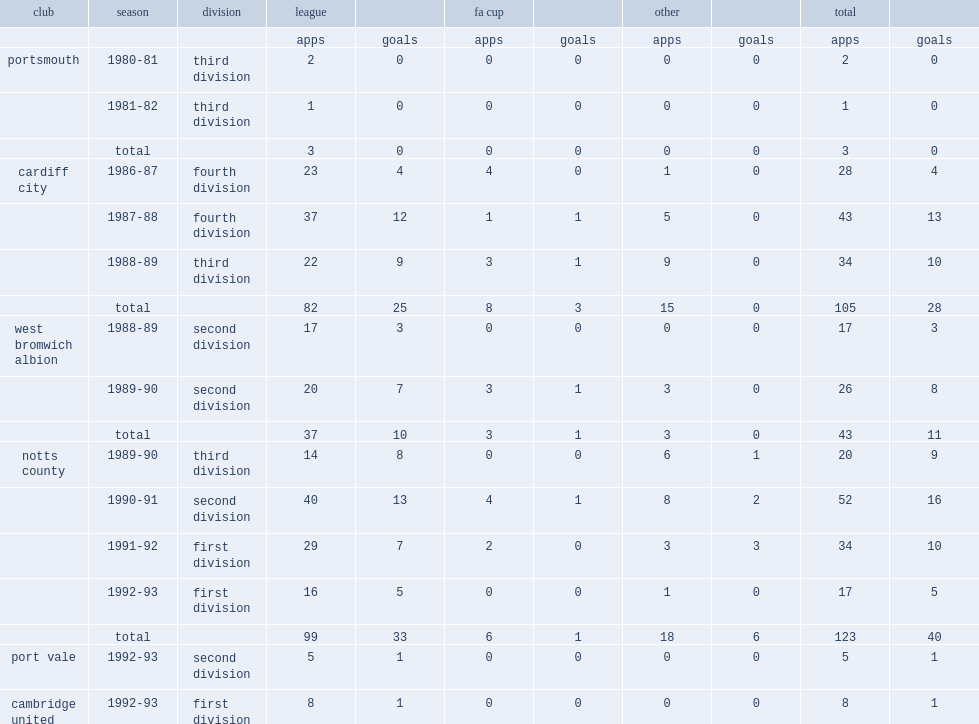Parse the table in full. {'header': ['club', 'season', 'division', 'league', '', 'fa cup', '', 'other', '', 'total', ''], 'rows': [['', '', '', 'apps', 'goals', 'apps', 'goals', 'apps', 'goals', 'apps', 'goals'], ['portsmouth', '1980-81', 'third division', '2', '0', '0', '0', '0', '0', '2', '0'], ['', '1981-82', 'third division', '1', '0', '0', '0', '0', '0', '1', '0'], ['', 'total', '', '3', '0', '0', '0', '0', '0', '3', '0'], ['cardiff city', '1986-87', 'fourth division', '23', '4', '4', '0', '1', '0', '28', '4'], ['', '1987-88', 'fourth division', '37', '12', '1', '1', '5', '0', '43', '13'], ['', '1988-89', 'third division', '22', '9', '3', '1', '9', '0', '34', '10'], ['', 'total', '', '82', '25', '8', '3', '15', '0', '105', '28'], ['west bromwich albion', '1988-89', 'second division', '17', '3', '0', '0', '0', '0', '17', '3'], ['', '1989-90', 'second division', '20', '7', '3', '1', '3', '0', '26', '8'], ['', 'total', '', '37', '10', '3', '1', '3', '0', '43', '11'], ['notts county', '1989-90', 'third division', '14', '8', '0', '0', '6', '1', '20', '9'], ['', '1990-91', 'second division', '40', '13', '4', '1', '8', '2', '52', '16'], ['', '1991-92', 'first division', '29', '7', '2', '0', '3', '3', '34', '10'], ['', '1992-93', 'first division', '16', '5', '0', '0', '1', '0', '17', '5'], ['', 'total', '', '99', '33', '6', '1', '18', '6', '123', '40'], ['port vale', '1992-93', 'second division', '5', '1', '0', '0', '0', '0', '5', '1'], ['cambridge united', '1992-93', 'first division', '8', '1', '0', '0', '0', '0', '8', '1']]} In 1987-88, which division did kevin bartlett join cardiff city with? Fourth division. 